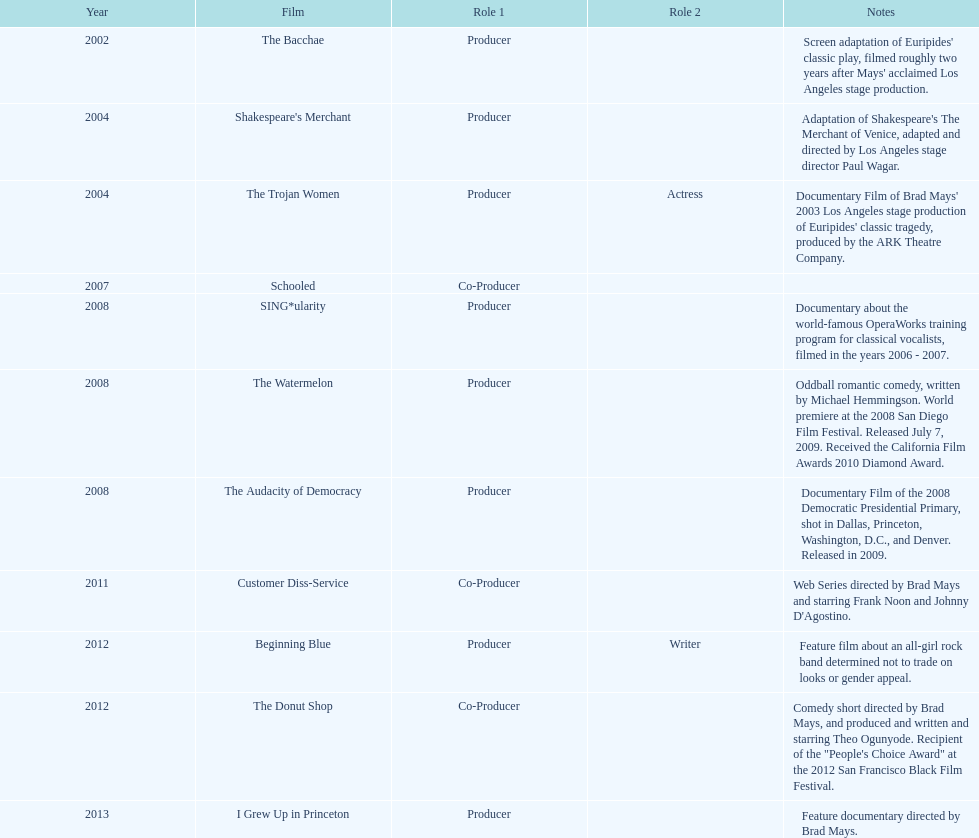Which year was there at least three movies? 2008. Parse the full table. {'header': ['Year', 'Film', 'Role 1', 'Role 2', 'Notes'], 'rows': [['2002', 'The Bacchae', 'Producer', '', "Screen adaptation of Euripides' classic play, filmed roughly two years after Mays' acclaimed Los Angeles stage production."], ['2004', "Shakespeare's Merchant", 'Producer', '', "Adaptation of Shakespeare's The Merchant of Venice, adapted and directed by Los Angeles stage director Paul Wagar."], ['2004', 'The Trojan Women', 'Producer', 'Actress', "Documentary Film of Brad Mays' 2003 Los Angeles stage production of Euripides' classic tragedy, produced by the ARK Theatre Company."], ['2007', 'Schooled', 'Co-Producer', '', ''], ['2008', 'SING*ularity', 'Producer', '', 'Documentary about the world-famous OperaWorks training program for classical vocalists, filmed in the years 2006 - 2007.'], ['2008', 'The Watermelon', 'Producer', '', 'Oddball romantic comedy, written by Michael Hemmingson. World premiere at the 2008 San Diego Film Festival. Released July 7, 2009. Received the California Film Awards 2010 Diamond Award.'], ['2008', 'The Audacity of Democracy', 'Producer', '', 'Documentary Film of the 2008 Democratic Presidential Primary, shot in Dallas, Princeton, Washington, D.C., and Denver. Released in 2009.'], ['2011', 'Customer Diss-Service', 'Co-Producer', '', "Web Series directed by Brad Mays and starring Frank Noon and Johnny D'Agostino."], ['2012', 'Beginning Blue', 'Producer', 'Writer', 'Feature film about an all-girl rock band determined not to trade on looks or gender appeal.'], ['2012', 'The Donut Shop', 'Co-Producer', '', 'Comedy short directed by Brad Mays, and produced and written and starring Theo Ogunyode. Recipient of the "People\'s Choice Award" at the 2012 San Francisco Black Film Festival.'], ['2013', 'I Grew Up in Princeton', 'Producer', '', 'Feature documentary directed by Brad Mays.']]} 